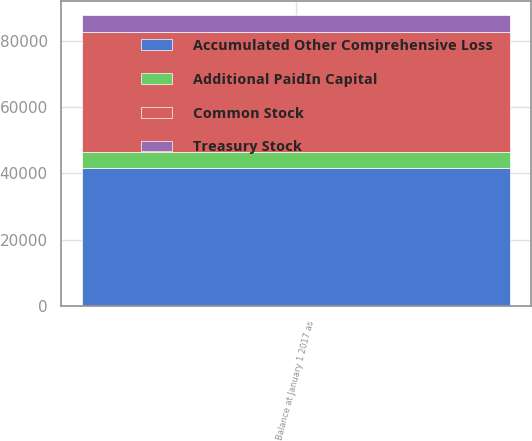Convert chart. <chart><loc_0><loc_0><loc_500><loc_500><stacked_bar_chart><ecel><fcel>Balance at January 1 2017 as<nl><fcel>Treasury Stock<fcel>5061<nl><fcel>Additional PaidIn Capital<fcel>4762<nl><fcel>Common Stock<fcel>36097<nl><fcel>Accumulated Other Comprehensive Loss<fcel>41754<nl></chart> 